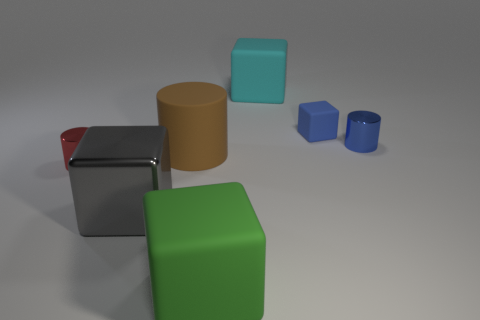What is the material of the big gray block?
Provide a short and direct response. Metal. What color is the rubber thing that is behind the small blue object on the left side of the metal thing behind the brown matte cylinder?
Your response must be concise. Cyan. What number of blue objects are the same size as the blue cylinder?
Provide a succinct answer. 1. There is a large rubber block behind the large green matte object; what is its color?
Ensure brevity in your answer.  Cyan. How many other things are there of the same size as the green object?
Your answer should be very brief. 3. What is the size of the object that is to the left of the blue matte block and to the right of the green rubber cube?
Provide a short and direct response. Large. Does the small cube have the same color as the tiny metal thing that is behind the red metallic thing?
Make the answer very short. Yes. Is there another matte thing that has the same shape as the large cyan thing?
Ensure brevity in your answer.  Yes. How many things are tiny metal cylinders or rubber things behind the large brown matte object?
Offer a very short reply. 4. What number of other objects are the same material as the green object?
Give a very brief answer. 3. 